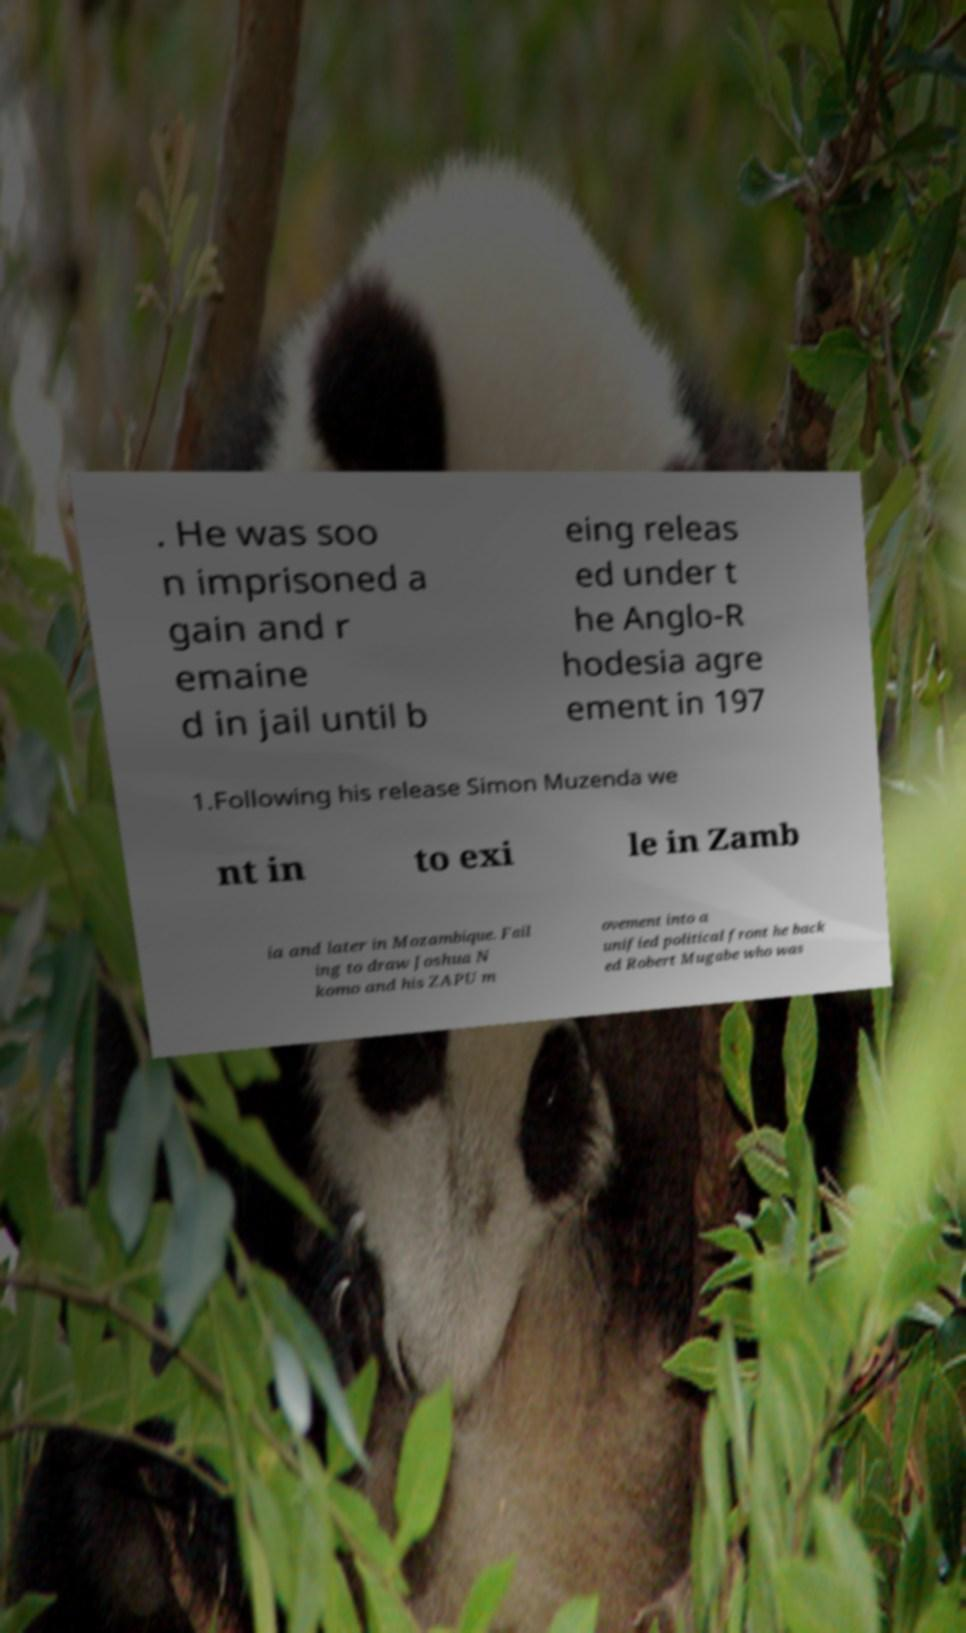Please identify and transcribe the text found in this image. . He was soo n imprisoned a gain and r emaine d in jail until b eing releas ed under t he Anglo-R hodesia agre ement in 197 1.Following his release Simon Muzenda we nt in to exi le in Zamb ia and later in Mozambique. Fail ing to draw Joshua N komo and his ZAPU m ovement into a unified political front he back ed Robert Mugabe who was 